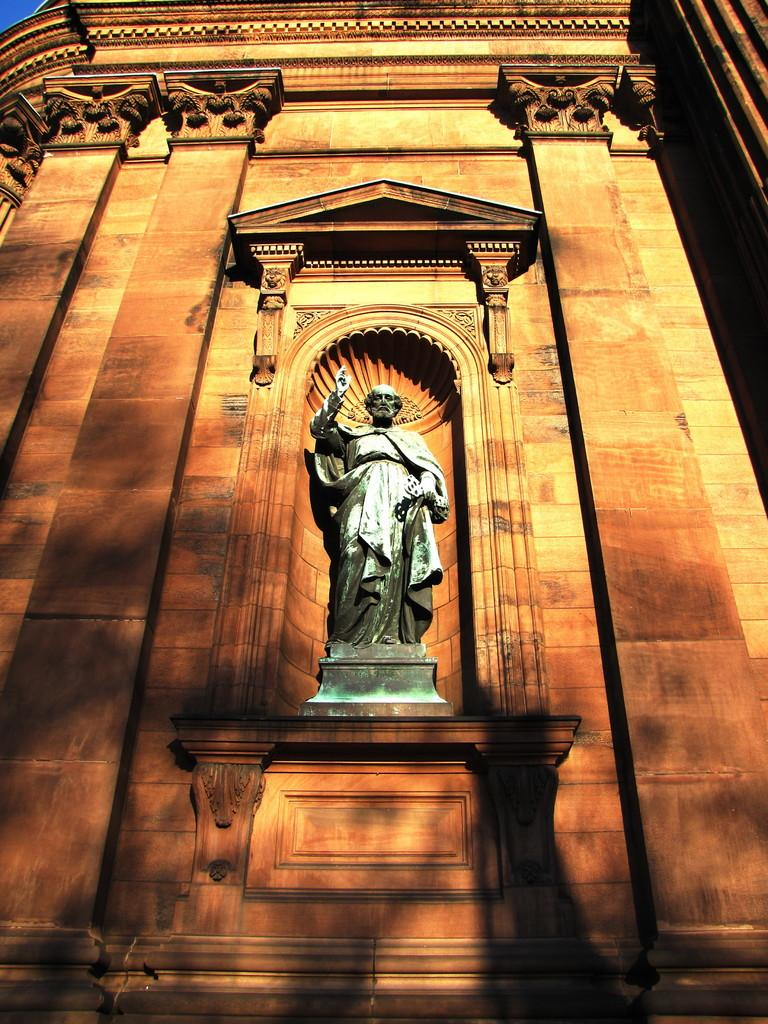What is the main subject in the image? There is a statue in the image. What else can be seen in the image besides the statue? There is a building in the image. What type of cap is the statue wearing in the image? There is no cap present on the statue in the image. What kind of oatmeal can be seen on the plate next to the statue? There is no plate or oatmeal present in the image. 